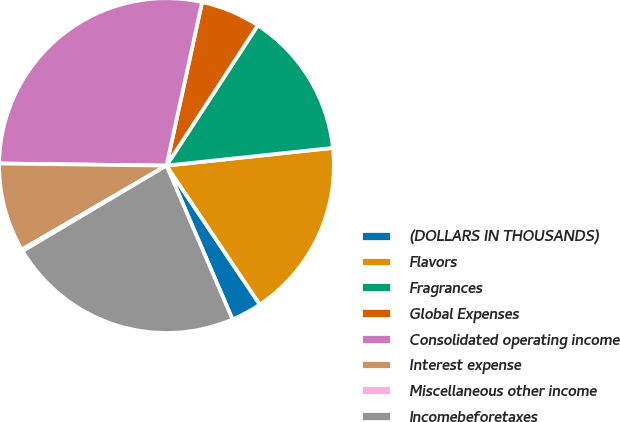Convert chart. <chart><loc_0><loc_0><loc_500><loc_500><pie_chart><fcel>(DOLLARS IN THOUSANDS)<fcel>Flavors<fcel>Fragrances<fcel>Global Expenses<fcel>Consolidated operating income<fcel>Interest expense<fcel>Miscellaneous other income<fcel>Incomebeforetaxes<nl><fcel>2.96%<fcel>17.27%<fcel>14.13%<fcel>5.77%<fcel>28.21%<fcel>8.57%<fcel>0.16%<fcel>22.92%<nl></chart> 